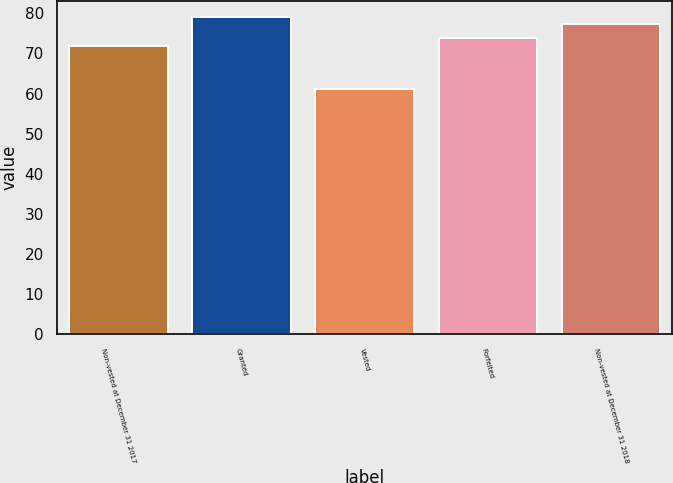Convert chart to OTSL. <chart><loc_0><loc_0><loc_500><loc_500><bar_chart><fcel>Non-vested at December 31 2017<fcel>Granted<fcel>Vested<fcel>Forfeited<fcel>Non-vested at December 31 2018<nl><fcel>71.93<fcel>79.11<fcel>61.03<fcel>73.97<fcel>77.42<nl></chart> 